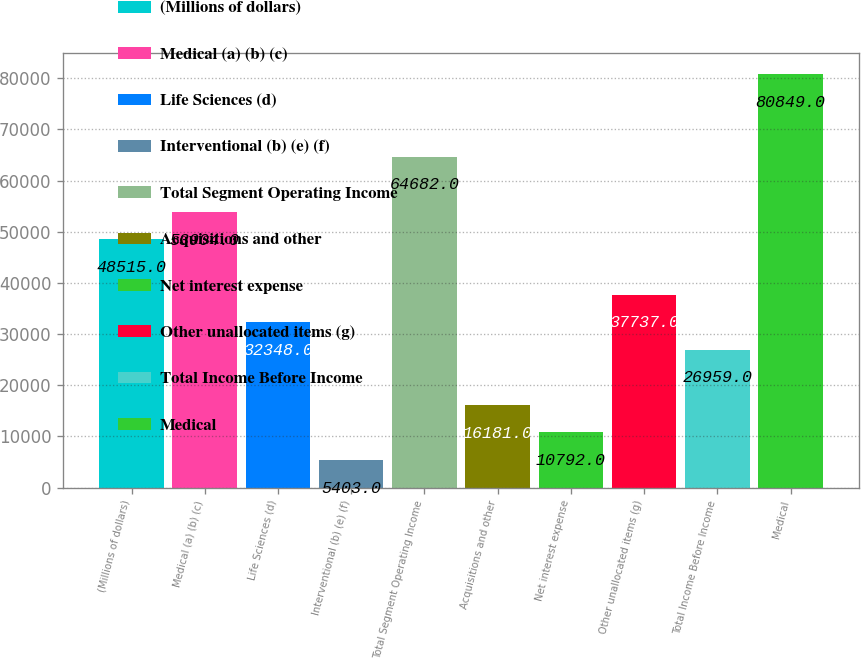Convert chart to OTSL. <chart><loc_0><loc_0><loc_500><loc_500><bar_chart><fcel>(Millions of dollars)<fcel>Medical (a) (b) (c)<fcel>Life Sciences (d)<fcel>Interventional (b) (e) (f)<fcel>Total Segment Operating Income<fcel>Acquisitions and other<fcel>Net interest expense<fcel>Other unallocated items (g)<fcel>Total Income Before Income<fcel>Medical<nl><fcel>48515<fcel>53904<fcel>32348<fcel>5403<fcel>64682<fcel>16181<fcel>10792<fcel>37737<fcel>26959<fcel>80849<nl></chart> 